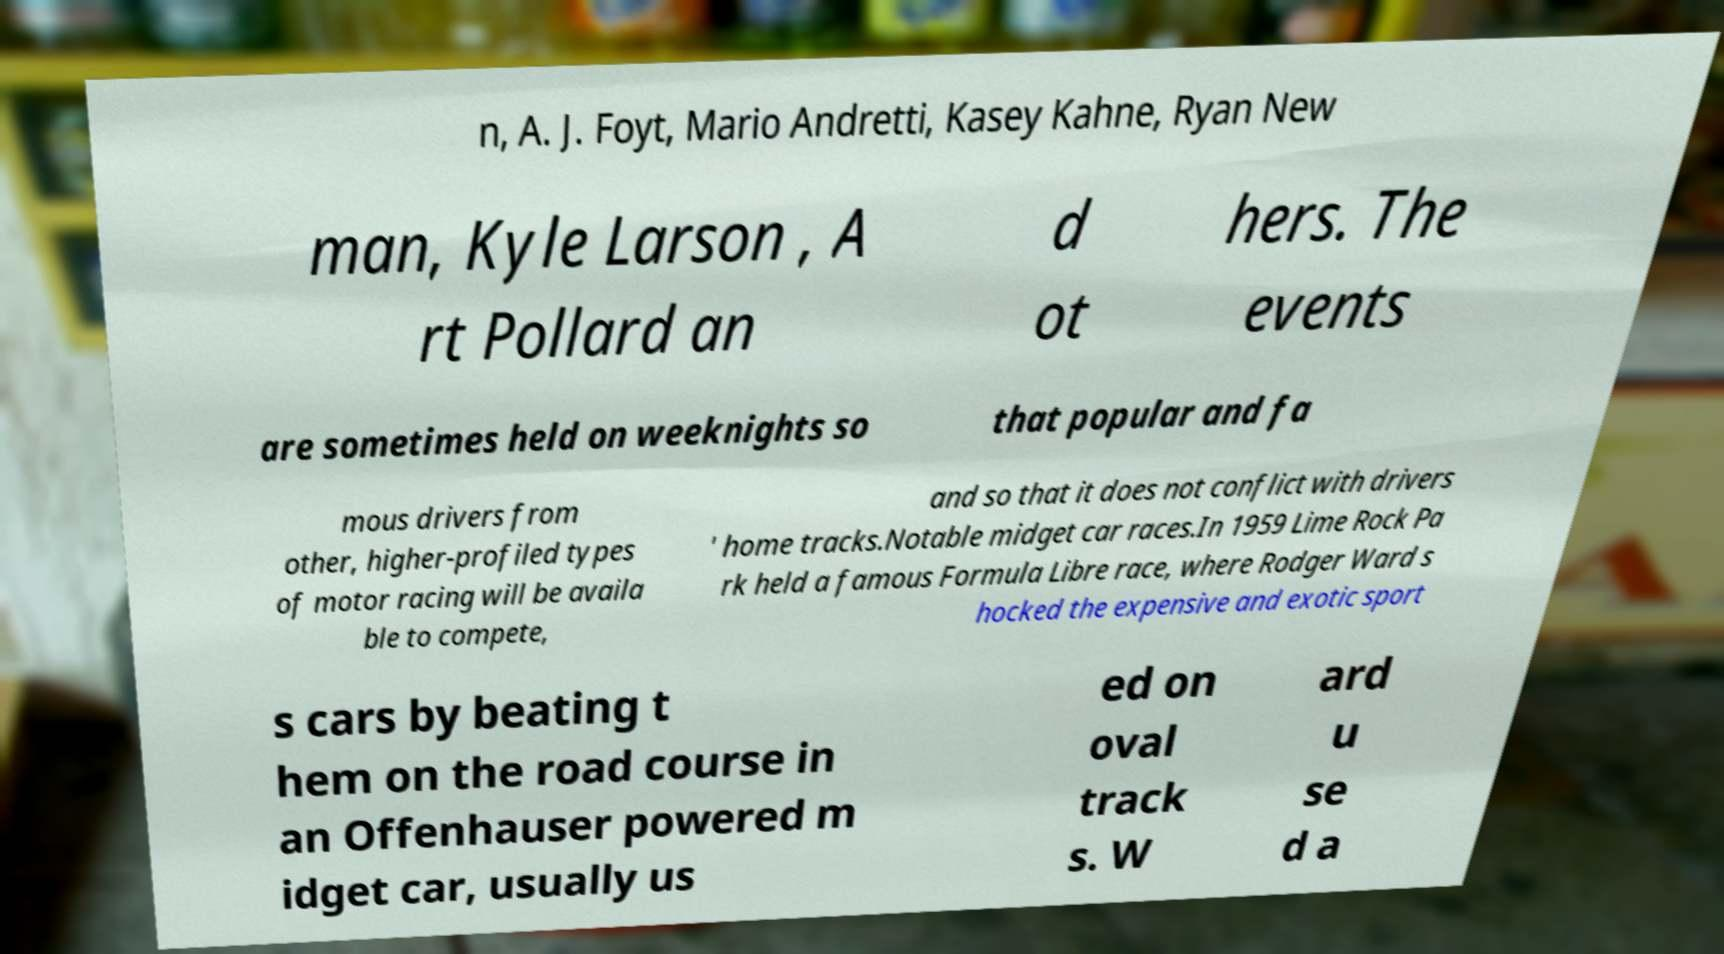For documentation purposes, I need the text within this image transcribed. Could you provide that? n, A. J. Foyt, Mario Andretti, Kasey Kahne, Ryan New man, Kyle Larson , A rt Pollard an d ot hers. The events are sometimes held on weeknights so that popular and fa mous drivers from other, higher-profiled types of motor racing will be availa ble to compete, and so that it does not conflict with drivers ' home tracks.Notable midget car races.In 1959 Lime Rock Pa rk held a famous Formula Libre race, where Rodger Ward s hocked the expensive and exotic sport s cars by beating t hem on the road course in an Offenhauser powered m idget car, usually us ed on oval track s. W ard u se d a 